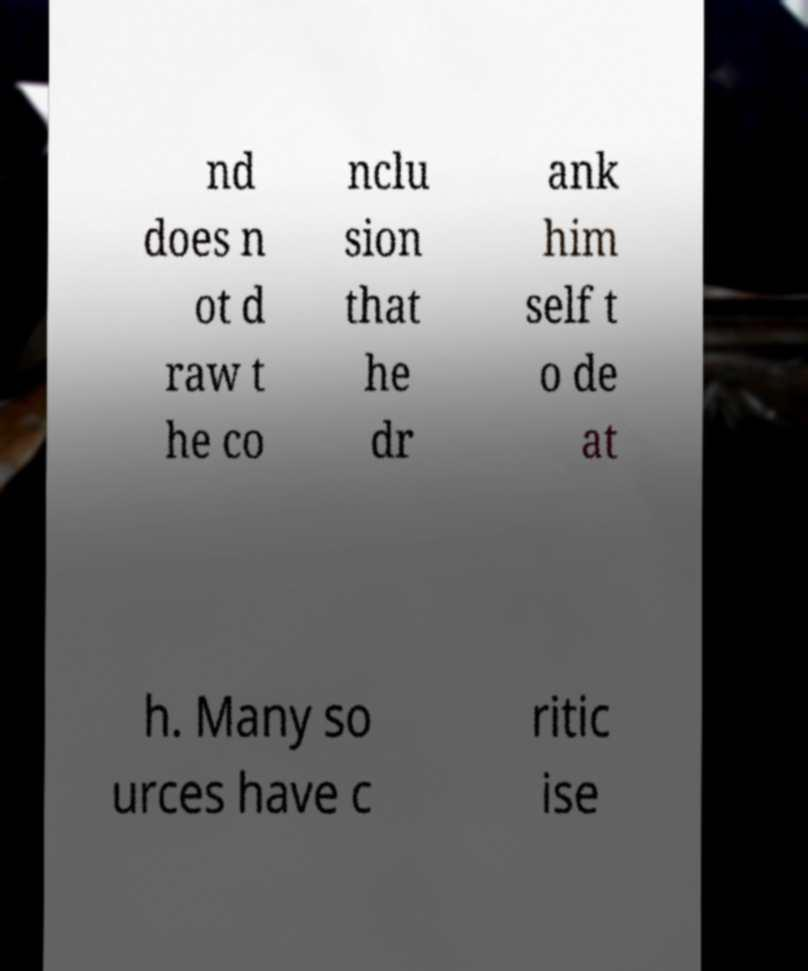Please identify and transcribe the text found in this image. nd does n ot d raw t he co nclu sion that he dr ank him self t o de at h. Many so urces have c ritic ise 